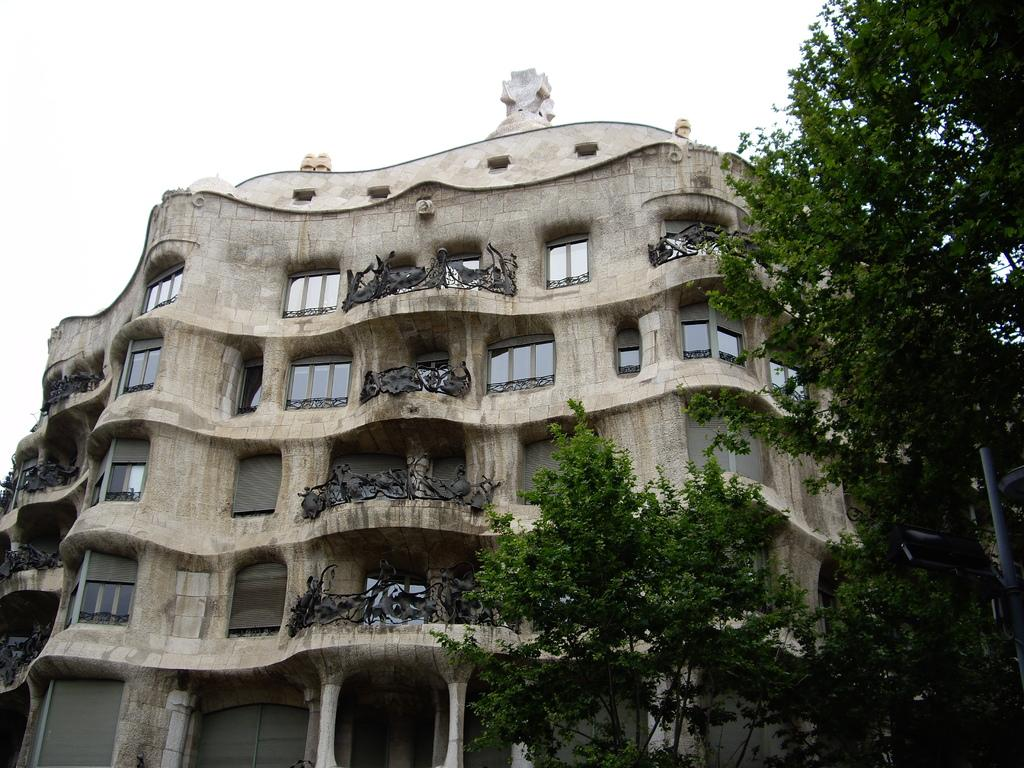What type of structure is visible in the image? There is a building in the image. What feature can be seen on the building? The building has windows. What is located on the right side of the image? There are trees and a pole on the right side of the image. What color is the brain that is floating in the air in the image? There is no brain or floating objects present in the image. 